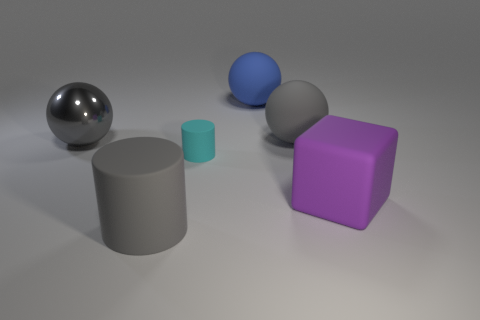Is there anything else that is the same size as the cyan object?
Give a very brief answer. No. What is the material of the large thing behind the big gray ball right of the gray sphere left of the blue matte ball?
Keep it short and to the point. Rubber. How many things are balls or large cylinders?
Provide a short and direct response. 4. Do the gray cylinder that is in front of the tiny cyan thing and the big blue thing have the same material?
Keep it short and to the point. Yes. How many things are either gray objects that are right of the blue sphere or small gray objects?
Your answer should be compact. 1. What color is the big cube that is made of the same material as the big cylinder?
Your answer should be very brief. Purple. Is there a rubber cylinder that has the same size as the purple rubber object?
Offer a terse response. Yes. Do the matte cylinder that is in front of the cube and the large metallic thing have the same color?
Provide a short and direct response. Yes. What color is the large object that is left of the blue matte thing and to the right of the gray metallic thing?
Offer a terse response. Gray. There is a gray metallic thing that is the same size as the blue rubber sphere; what shape is it?
Ensure brevity in your answer.  Sphere. 